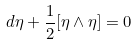Convert formula to latex. <formula><loc_0><loc_0><loc_500><loc_500>d \eta + \frac { 1 } { 2 } [ \eta \wedge \eta ] = 0</formula> 